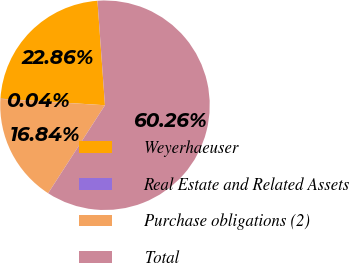Convert chart to OTSL. <chart><loc_0><loc_0><loc_500><loc_500><pie_chart><fcel>Weyerhaeuser<fcel>Real Estate and Related Assets<fcel>Purchase obligations (2)<fcel>Total<nl><fcel>22.86%<fcel>0.04%<fcel>16.84%<fcel>60.27%<nl></chart> 